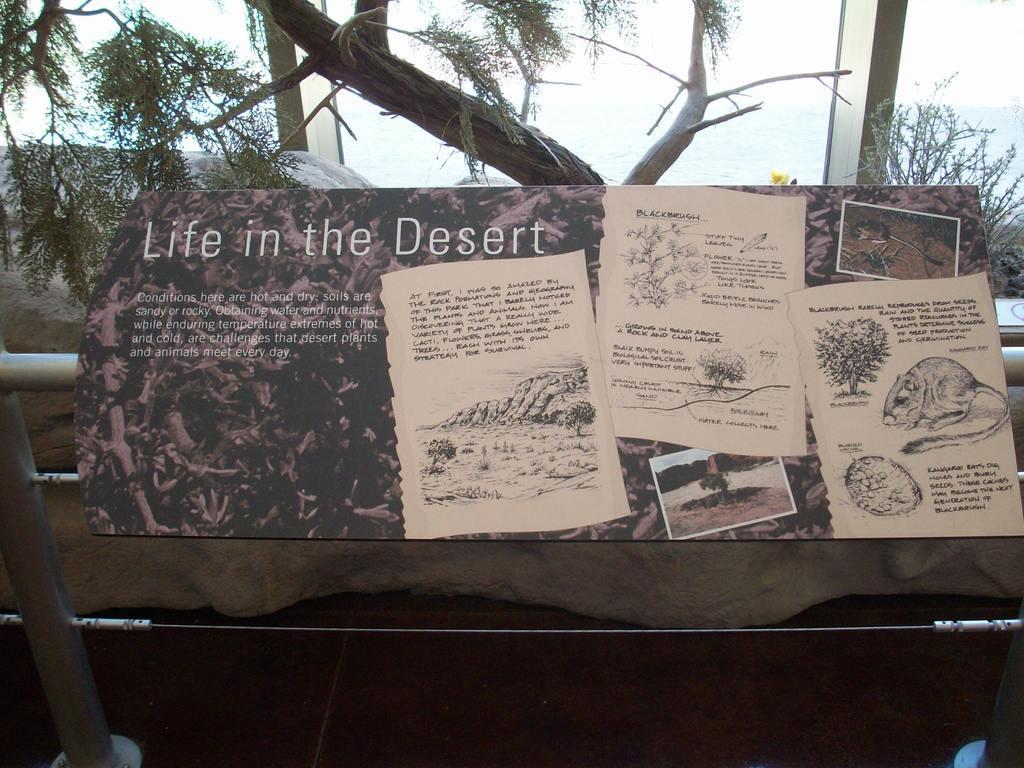Please provide a concise description of this image. In the picture we can see a board on it, we can see a name life in the desert and some articles posted on it and in the background we can see some tree and pole. 